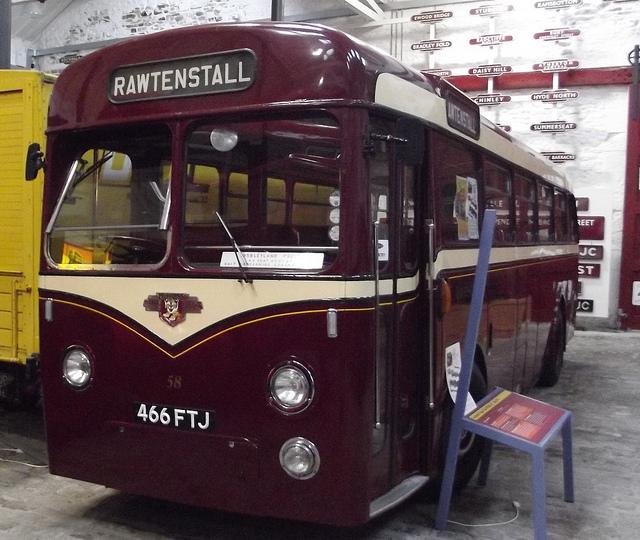What does the information on the blue legged placard describe?

Choices:
A) bus
B) motorcycle
C) menu
D) protest bus 